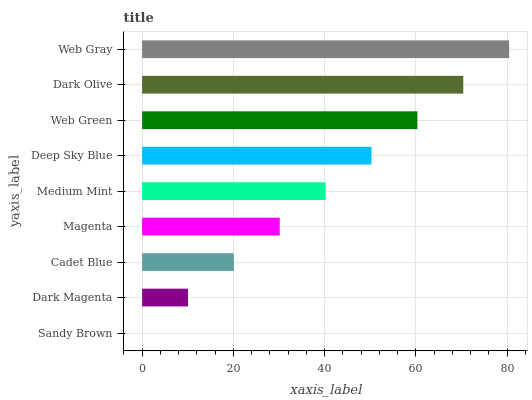Is Sandy Brown the minimum?
Answer yes or no. Yes. Is Web Gray the maximum?
Answer yes or no. Yes. Is Dark Magenta the minimum?
Answer yes or no. No. Is Dark Magenta the maximum?
Answer yes or no. No. Is Dark Magenta greater than Sandy Brown?
Answer yes or no. Yes. Is Sandy Brown less than Dark Magenta?
Answer yes or no. Yes. Is Sandy Brown greater than Dark Magenta?
Answer yes or no. No. Is Dark Magenta less than Sandy Brown?
Answer yes or no. No. Is Medium Mint the high median?
Answer yes or no. Yes. Is Medium Mint the low median?
Answer yes or no. Yes. Is Dark Magenta the high median?
Answer yes or no. No. Is Web Green the low median?
Answer yes or no. No. 